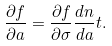Convert formula to latex. <formula><loc_0><loc_0><loc_500><loc_500>\frac { \partial f } { \partial a } = \frac { \partial f } { \partial \sigma } \frac { d n } { d a } t .</formula> 